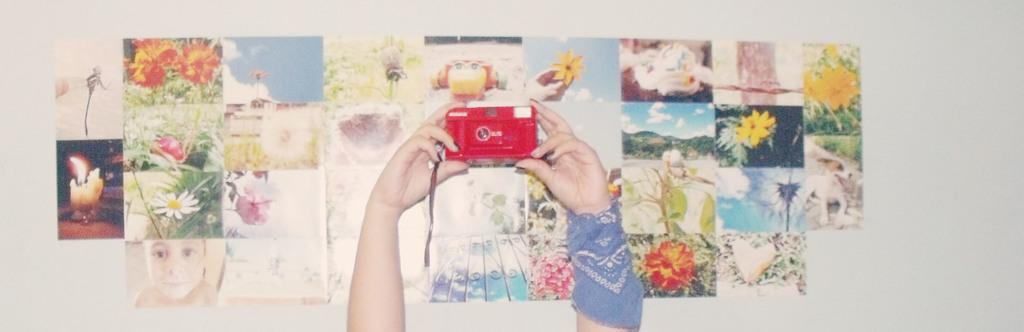What is the main subject of the image? The main subject of the image is a human hand holding a camera. Can you describe the camera in the image? The camera is red. What can be seen in the background of the image? There are papers attached to a white wall in the background of the image. What type of treatment is being administered to the earth in the image? There is no reference to the earth or any treatment in the image; it features a human hand holding a red camera. 